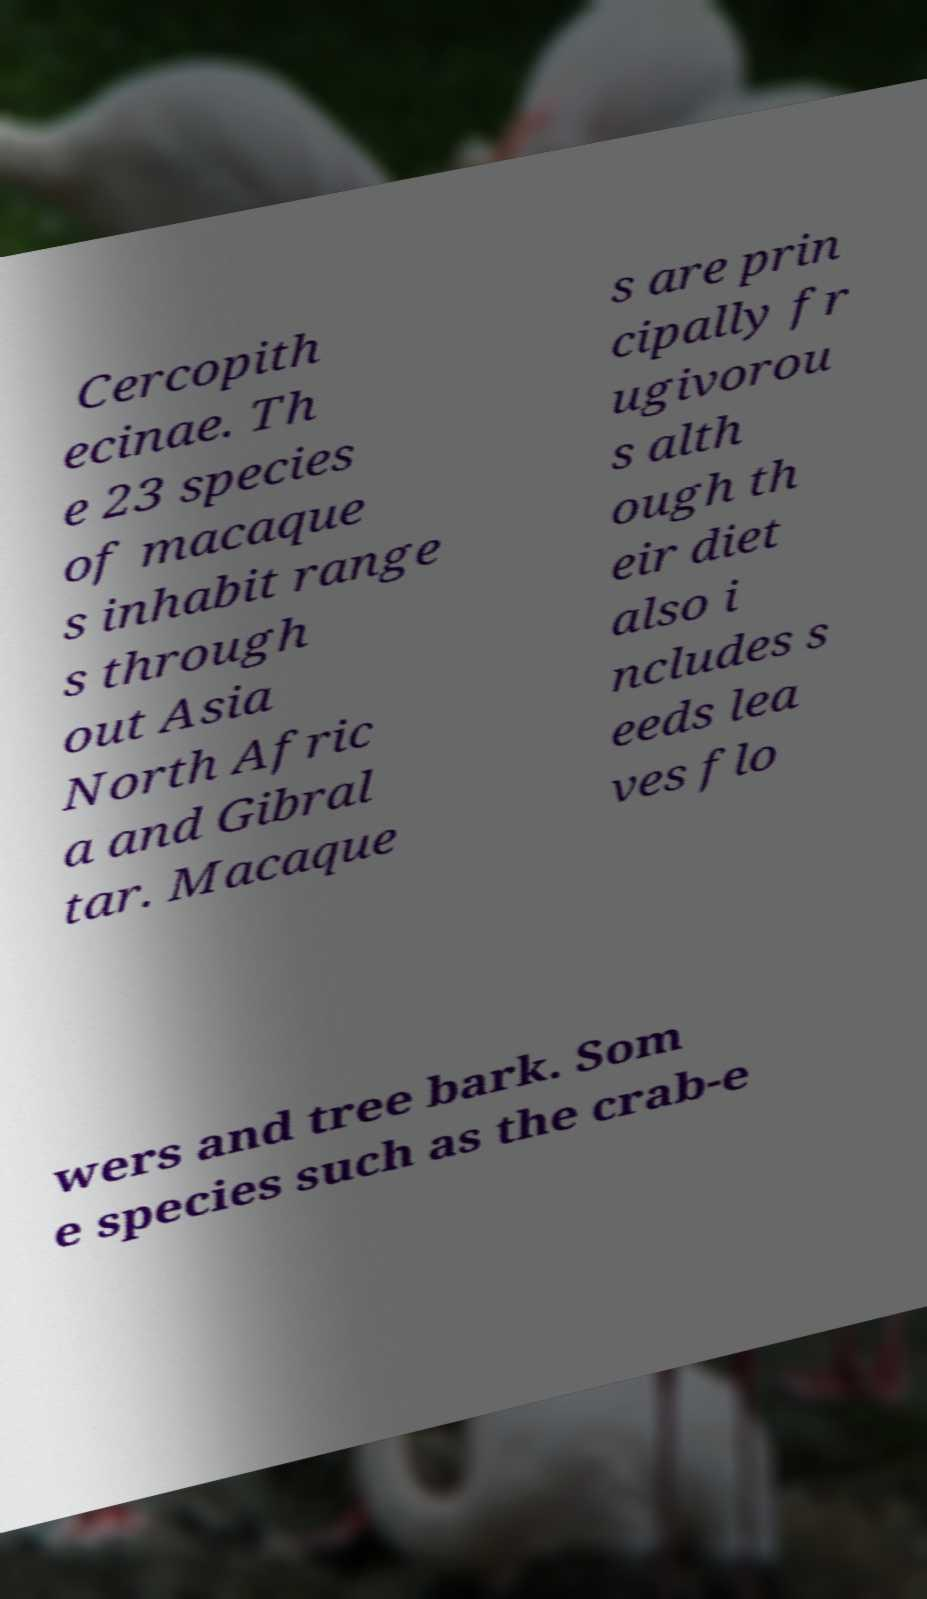Please identify and transcribe the text found in this image. Cercopith ecinae. Th e 23 species of macaque s inhabit range s through out Asia North Afric a and Gibral tar. Macaque s are prin cipally fr ugivorou s alth ough th eir diet also i ncludes s eeds lea ves flo wers and tree bark. Som e species such as the crab-e 